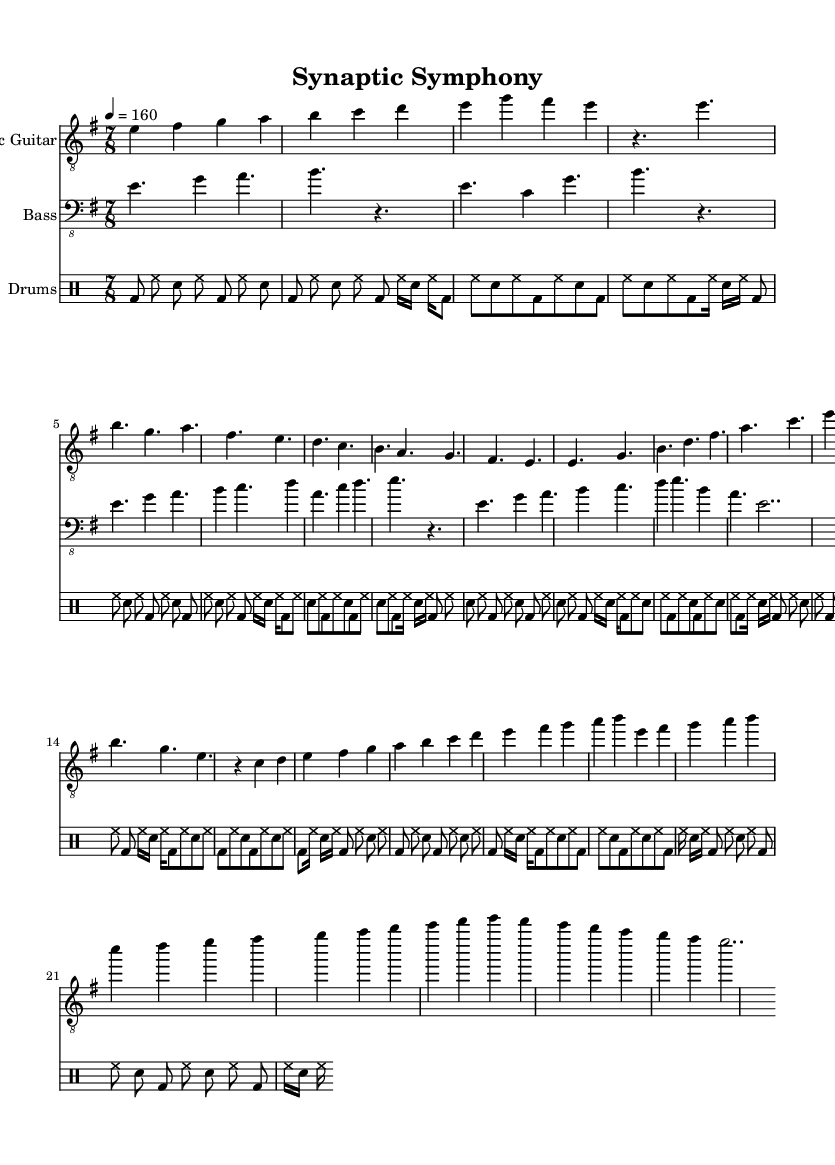What is the key signature of this music? The key signature can be identified at the beginning of the staff. It shows one sharp, indicating that the key is E minor, which has one sharp (F#).
Answer: E minor What is the time signature of the piece? The time signature is located in the first measure. It indicates a 7/8 time signature, meaning there are seven eighth notes per measure.
Answer: 7/8 What is the tempo marking for this piece? The tempo is indicated at the beginning of the score, showing a metronome marking of 160 beats per minute.
Answer: 160 How many sections are in the piece? By examining the layout of the music, we can see distinct parts such as Intro, Verse, Chorus, Bridge, Solo, and Outro. This totals to six different sections.
Answer: Six What is the main rhythmic pattern of the drums? The drumming section indicates a repeating pattern throughout the piece. The basic groove involves a combination of bass drum, hi-hat, and snare drum, showing a consistent rhythmic structure. The main pattern is established early in the drum part.
Answer: Basic groove What is the highest note played by the electric guitar? Looking at the notes in the electric guitar staff, we can observe that the highest note in the piece is the note B, which can be found in various sections, particularly during the solo.
Answer: B 